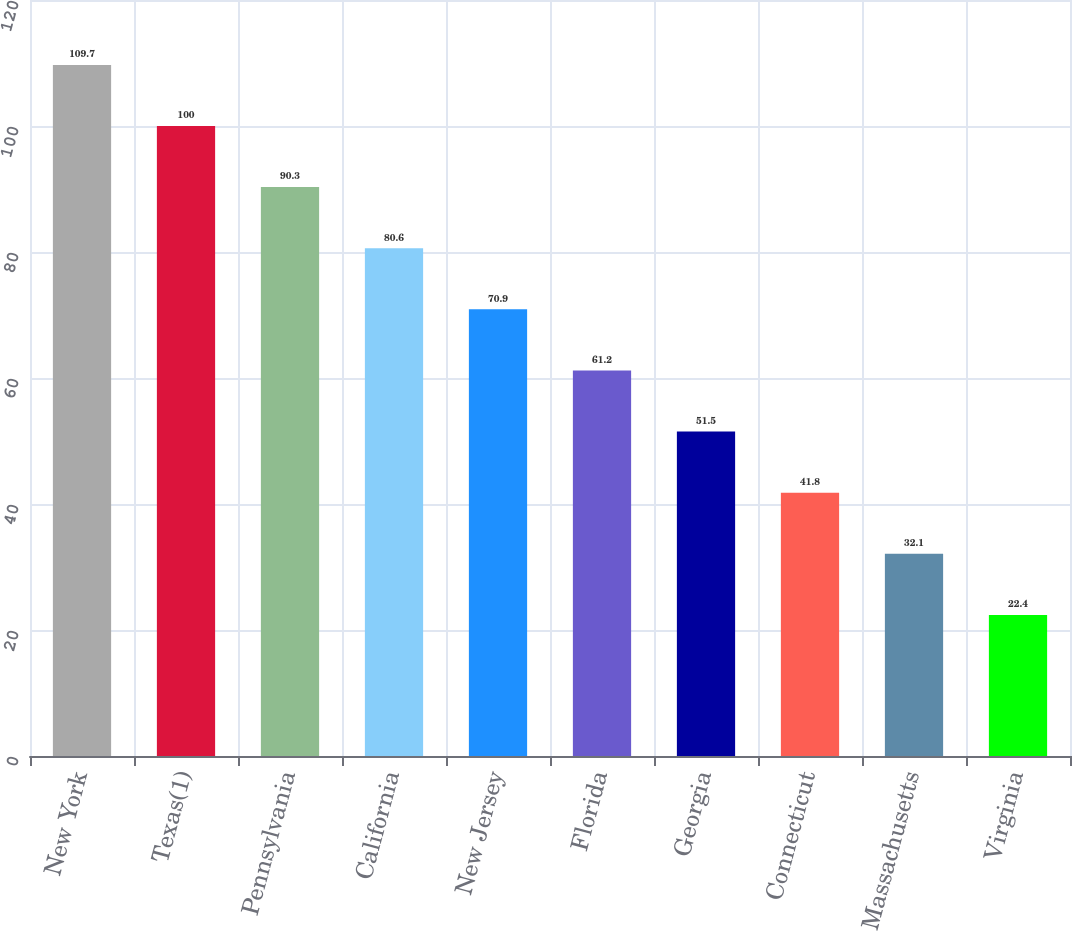Convert chart to OTSL. <chart><loc_0><loc_0><loc_500><loc_500><bar_chart><fcel>New York<fcel>Texas(1)<fcel>Pennsylvania<fcel>California<fcel>New Jersey<fcel>Florida<fcel>Georgia<fcel>Connecticut<fcel>Massachusetts<fcel>Virginia<nl><fcel>109.7<fcel>100<fcel>90.3<fcel>80.6<fcel>70.9<fcel>61.2<fcel>51.5<fcel>41.8<fcel>32.1<fcel>22.4<nl></chart> 